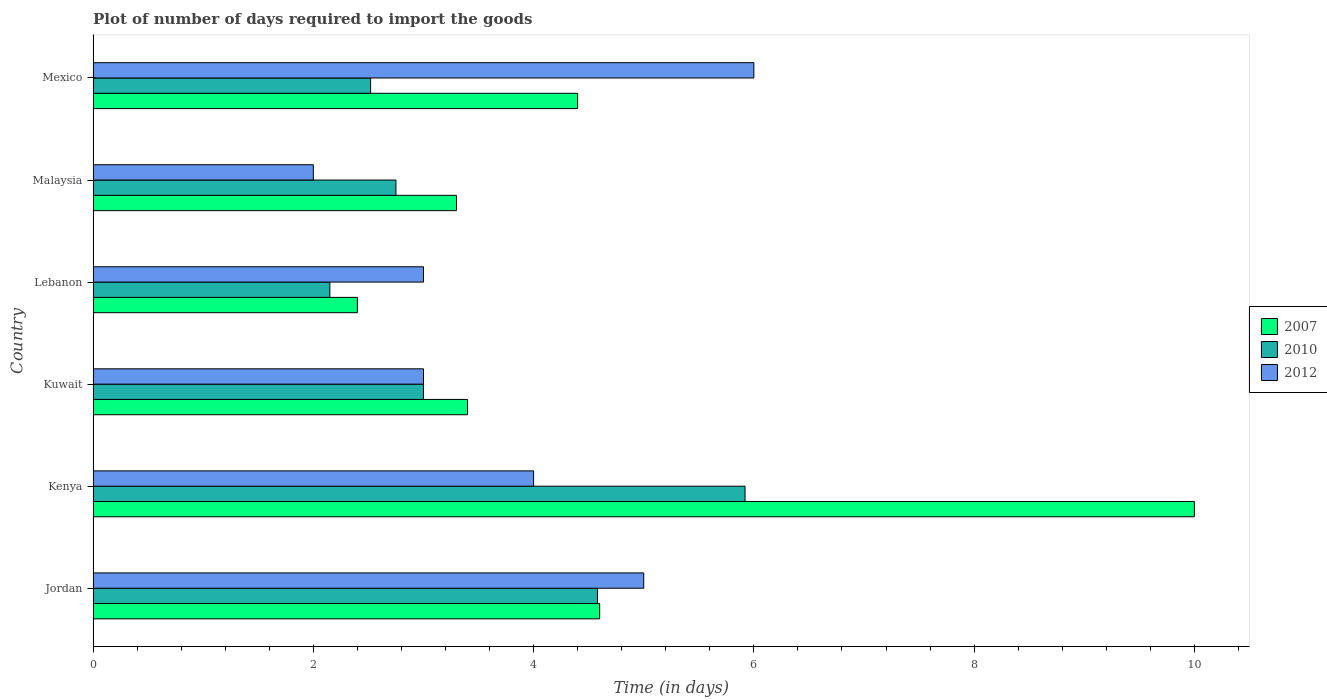How many different coloured bars are there?
Your response must be concise. 3. Are the number of bars per tick equal to the number of legend labels?
Your answer should be compact. Yes. What is the label of the 5th group of bars from the top?
Keep it short and to the point. Kenya. What is the time required to import goods in 2010 in Mexico?
Provide a short and direct response. 2.52. Across all countries, what is the maximum time required to import goods in 2007?
Your response must be concise. 10. Across all countries, what is the minimum time required to import goods in 2010?
Offer a terse response. 2.15. In which country was the time required to import goods in 2007 maximum?
Make the answer very short. Kenya. In which country was the time required to import goods in 2010 minimum?
Keep it short and to the point. Lebanon. What is the total time required to import goods in 2012 in the graph?
Your response must be concise. 23. What is the difference between the time required to import goods in 2007 in Kenya and that in Lebanon?
Give a very brief answer. 7.6. What is the difference between the time required to import goods in 2012 in Jordan and the time required to import goods in 2007 in Mexico?
Provide a short and direct response. 0.6. What is the average time required to import goods in 2007 per country?
Offer a terse response. 4.68. What is the difference between the time required to import goods in 2007 and time required to import goods in 2010 in Lebanon?
Keep it short and to the point. 0.25. In how many countries, is the time required to import goods in 2010 greater than 3.2 days?
Your response must be concise. 2. What is the ratio of the time required to import goods in 2010 in Jordan to that in Kuwait?
Offer a terse response. 1.53. Is the time required to import goods in 2010 in Kenya less than that in Malaysia?
Make the answer very short. No. Is the difference between the time required to import goods in 2007 in Kenya and Lebanon greater than the difference between the time required to import goods in 2010 in Kenya and Lebanon?
Offer a very short reply. Yes. What is the difference between the highest and the second highest time required to import goods in 2012?
Make the answer very short. 1. In how many countries, is the time required to import goods in 2012 greater than the average time required to import goods in 2012 taken over all countries?
Ensure brevity in your answer.  3. Is the sum of the time required to import goods in 2012 in Jordan and Malaysia greater than the maximum time required to import goods in 2010 across all countries?
Keep it short and to the point. Yes. Is it the case that in every country, the sum of the time required to import goods in 2012 and time required to import goods in 2010 is greater than the time required to import goods in 2007?
Your answer should be very brief. No. How many bars are there?
Your response must be concise. 18. Are all the bars in the graph horizontal?
Your response must be concise. Yes. What is the difference between two consecutive major ticks on the X-axis?
Keep it short and to the point. 2. Are the values on the major ticks of X-axis written in scientific E-notation?
Make the answer very short. No. Does the graph contain any zero values?
Provide a succinct answer. No. How many legend labels are there?
Offer a very short reply. 3. What is the title of the graph?
Ensure brevity in your answer.  Plot of number of days required to import the goods. Does "2009" appear as one of the legend labels in the graph?
Provide a succinct answer. No. What is the label or title of the X-axis?
Your answer should be very brief. Time (in days). What is the label or title of the Y-axis?
Give a very brief answer. Country. What is the Time (in days) of 2007 in Jordan?
Offer a terse response. 4.6. What is the Time (in days) in 2010 in Jordan?
Your answer should be very brief. 4.58. What is the Time (in days) in 2007 in Kenya?
Your answer should be very brief. 10. What is the Time (in days) in 2010 in Kenya?
Provide a short and direct response. 5.92. What is the Time (in days) in 2007 in Kuwait?
Offer a very short reply. 3.4. What is the Time (in days) of 2007 in Lebanon?
Your response must be concise. 2.4. What is the Time (in days) in 2010 in Lebanon?
Keep it short and to the point. 2.15. What is the Time (in days) in 2012 in Lebanon?
Offer a terse response. 3. What is the Time (in days) of 2007 in Malaysia?
Your answer should be compact. 3.3. What is the Time (in days) of 2010 in Malaysia?
Provide a succinct answer. 2.75. What is the Time (in days) of 2012 in Malaysia?
Give a very brief answer. 2. What is the Time (in days) in 2007 in Mexico?
Offer a very short reply. 4.4. What is the Time (in days) in 2010 in Mexico?
Keep it short and to the point. 2.52. Across all countries, what is the maximum Time (in days) of 2007?
Your answer should be very brief. 10. Across all countries, what is the maximum Time (in days) in 2010?
Ensure brevity in your answer.  5.92. Across all countries, what is the minimum Time (in days) in 2010?
Keep it short and to the point. 2.15. What is the total Time (in days) of 2007 in the graph?
Make the answer very short. 28.1. What is the total Time (in days) of 2010 in the graph?
Provide a short and direct response. 20.92. What is the total Time (in days) in 2012 in the graph?
Make the answer very short. 23. What is the difference between the Time (in days) in 2010 in Jordan and that in Kenya?
Provide a short and direct response. -1.34. What is the difference between the Time (in days) of 2010 in Jordan and that in Kuwait?
Ensure brevity in your answer.  1.58. What is the difference between the Time (in days) in 2007 in Jordan and that in Lebanon?
Your answer should be very brief. 2.2. What is the difference between the Time (in days) in 2010 in Jordan and that in Lebanon?
Make the answer very short. 2.43. What is the difference between the Time (in days) in 2007 in Jordan and that in Malaysia?
Provide a short and direct response. 1.3. What is the difference between the Time (in days) of 2010 in Jordan and that in Malaysia?
Provide a short and direct response. 1.83. What is the difference between the Time (in days) in 2010 in Jordan and that in Mexico?
Keep it short and to the point. 2.06. What is the difference between the Time (in days) in 2012 in Jordan and that in Mexico?
Give a very brief answer. -1. What is the difference between the Time (in days) in 2007 in Kenya and that in Kuwait?
Give a very brief answer. 6.6. What is the difference between the Time (in days) in 2010 in Kenya and that in Kuwait?
Give a very brief answer. 2.92. What is the difference between the Time (in days) of 2012 in Kenya and that in Kuwait?
Provide a succinct answer. 1. What is the difference between the Time (in days) in 2007 in Kenya and that in Lebanon?
Ensure brevity in your answer.  7.6. What is the difference between the Time (in days) in 2010 in Kenya and that in Lebanon?
Your response must be concise. 3.77. What is the difference between the Time (in days) in 2012 in Kenya and that in Lebanon?
Your response must be concise. 1. What is the difference between the Time (in days) in 2010 in Kenya and that in Malaysia?
Ensure brevity in your answer.  3.17. What is the difference between the Time (in days) in 2012 in Kenya and that in Malaysia?
Give a very brief answer. 2. What is the difference between the Time (in days) in 2007 in Kenya and that in Mexico?
Give a very brief answer. 5.6. What is the difference between the Time (in days) in 2010 in Kenya and that in Mexico?
Provide a short and direct response. 3.4. What is the difference between the Time (in days) of 2012 in Kenya and that in Mexico?
Your answer should be compact. -2. What is the difference between the Time (in days) of 2012 in Kuwait and that in Malaysia?
Ensure brevity in your answer.  1. What is the difference between the Time (in days) of 2010 in Kuwait and that in Mexico?
Keep it short and to the point. 0.48. What is the difference between the Time (in days) of 2012 in Kuwait and that in Mexico?
Keep it short and to the point. -3. What is the difference between the Time (in days) of 2007 in Lebanon and that in Malaysia?
Make the answer very short. -0.9. What is the difference between the Time (in days) in 2012 in Lebanon and that in Malaysia?
Offer a very short reply. 1. What is the difference between the Time (in days) of 2010 in Lebanon and that in Mexico?
Make the answer very short. -0.37. What is the difference between the Time (in days) in 2012 in Lebanon and that in Mexico?
Ensure brevity in your answer.  -3. What is the difference between the Time (in days) in 2010 in Malaysia and that in Mexico?
Ensure brevity in your answer.  0.23. What is the difference between the Time (in days) of 2007 in Jordan and the Time (in days) of 2010 in Kenya?
Your answer should be very brief. -1.32. What is the difference between the Time (in days) of 2010 in Jordan and the Time (in days) of 2012 in Kenya?
Keep it short and to the point. 0.58. What is the difference between the Time (in days) in 2007 in Jordan and the Time (in days) in 2012 in Kuwait?
Your response must be concise. 1.6. What is the difference between the Time (in days) of 2010 in Jordan and the Time (in days) of 2012 in Kuwait?
Your answer should be very brief. 1.58. What is the difference between the Time (in days) of 2007 in Jordan and the Time (in days) of 2010 in Lebanon?
Offer a very short reply. 2.45. What is the difference between the Time (in days) of 2010 in Jordan and the Time (in days) of 2012 in Lebanon?
Make the answer very short. 1.58. What is the difference between the Time (in days) of 2007 in Jordan and the Time (in days) of 2010 in Malaysia?
Provide a succinct answer. 1.85. What is the difference between the Time (in days) of 2010 in Jordan and the Time (in days) of 2012 in Malaysia?
Offer a very short reply. 2.58. What is the difference between the Time (in days) in 2007 in Jordan and the Time (in days) in 2010 in Mexico?
Your answer should be very brief. 2.08. What is the difference between the Time (in days) in 2010 in Jordan and the Time (in days) in 2012 in Mexico?
Keep it short and to the point. -1.42. What is the difference between the Time (in days) in 2007 in Kenya and the Time (in days) in 2012 in Kuwait?
Offer a terse response. 7. What is the difference between the Time (in days) in 2010 in Kenya and the Time (in days) in 2012 in Kuwait?
Your answer should be compact. 2.92. What is the difference between the Time (in days) in 2007 in Kenya and the Time (in days) in 2010 in Lebanon?
Give a very brief answer. 7.85. What is the difference between the Time (in days) of 2010 in Kenya and the Time (in days) of 2012 in Lebanon?
Provide a short and direct response. 2.92. What is the difference between the Time (in days) in 2007 in Kenya and the Time (in days) in 2010 in Malaysia?
Provide a short and direct response. 7.25. What is the difference between the Time (in days) of 2007 in Kenya and the Time (in days) of 2012 in Malaysia?
Offer a terse response. 8. What is the difference between the Time (in days) of 2010 in Kenya and the Time (in days) of 2012 in Malaysia?
Offer a terse response. 3.92. What is the difference between the Time (in days) in 2007 in Kenya and the Time (in days) in 2010 in Mexico?
Ensure brevity in your answer.  7.48. What is the difference between the Time (in days) of 2007 in Kenya and the Time (in days) of 2012 in Mexico?
Provide a short and direct response. 4. What is the difference between the Time (in days) of 2010 in Kenya and the Time (in days) of 2012 in Mexico?
Ensure brevity in your answer.  -0.08. What is the difference between the Time (in days) of 2007 in Kuwait and the Time (in days) of 2010 in Lebanon?
Provide a short and direct response. 1.25. What is the difference between the Time (in days) of 2007 in Kuwait and the Time (in days) of 2010 in Malaysia?
Ensure brevity in your answer.  0.65. What is the difference between the Time (in days) in 2007 in Kuwait and the Time (in days) in 2012 in Malaysia?
Make the answer very short. 1.4. What is the difference between the Time (in days) in 2007 in Lebanon and the Time (in days) in 2010 in Malaysia?
Make the answer very short. -0.35. What is the difference between the Time (in days) of 2007 in Lebanon and the Time (in days) of 2010 in Mexico?
Your answer should be very brief. -0.12. What is the difference between the Time (in days) of 2010 in Lebanon and the Time (in days) of 2012 in Mexico?
Keep it short and to the point. -3.85. What is the difference between the Time (in days) in 2007 in Malaysia and the Time (in days) in 2010 in Mexico?
Provide a short and direct response. 0.78. What is the difference between the Time (in days) of 2007 in Malaysia and the Time (in days) of 2012 in Mexico?
Your answer should be compact. -2.7. What is the difference between the Time (in days) of 2010 in Malaysia and the Time (in days) of 2012 in Mexico?
Keep it short and to the point. -3.25. What is the average Time (in days) of 2007 per country?
Make the answer very short. 4.68. What is the average Time (in days) of 2010 per country?
Your response must be concise. 3.49. What is the average Time (in days) in 2012 per country?
Give a very brief answer. 3.83. What is the difference between the Time (in days) in 2007 and Time (in days) in 2010 in Jordan?
Offer a terse response. 0.02. What is the difference between the Time (in days) of 2010 and Time (in days) of 2012 in Jordan?
Provide a succinct answer. -0.42. What is the difference between the Time (in days) of 2007 and Time (in days) of 2010 in Kenya?
Provide a short and direct response. 4.08. What is the difference between the Time (in days) in 2010 and Time (in days) in 2012 in Kenya?
Provide a short and direct response. 1.92. What is the difference between the Time (in days) in 2007 and Time (in days) in 2012 in Kuwait?
Offer a terse response. 0.4. What is the difference between the Time (in days) in 2007 and Time (in days) in 2010 in Lebanon?
Offer a terse response. 0.25. What is the difference between the Time (in days) in 2007 and Time (in days) in 2012 in Lebanon?
Make the answer very short. -0.6. What is the difference between the Time (in days) of 2010 and Time (in days) of 2012 in Lebanon?
Offer a terse response. -0.85. What is the difference between the Time (in days) in 2007 and Time (in days) in 2010 in Malaysia?
Make the answer very short. 0.55. What is the difference between the Time (in days) in 2007 and Time (in days) in 2012 in Malaysia?
Keep it short and to the point. 1.3. What is the difference between the Time (in days) in 2007 and Time (in days) in 2010 in Mexico?
Your response must be concise. 1.88. What is the difference between the Time (in days) in 2010 and Time (in days) in 2012 in Mexico?
Your answer should be compact. -3.48. What is the ratio of the Time (in days) of 2007 in Jordan to that in Kenya?
Keep it short and to the point. 0.46. What is the ratio of the Time (in days) in 2010 in Jordan to that in Kenya?
Your response must be concise. 0.77. What is the ratio of the Time (in days) of 2007 in Jordan to that in Kuwait?
Offer a terse response. 1.35. What is the ratio of the Time (in days) in 2010 in Jordan to that in Kuwait?
Your answer should be very brief. 1.53. What is the ratio of the Time (in days) of 2007 in Jordan to that in Lebanon?
Your answer should be very brief. 1.92. What is the ratio of the Time (in days) of 2010 in Jordan to that in Lebanon?
Offer a very short reply. 2.13. What is the ratio of the Time (in days) of 2007 in Jordan to that in Malaysia?
Give a very brief answer. 1.39. What is the ratio of the Time (in days) of 2010 in Jordan to that in Malaysia?
Your answer should be very brief. 1.67. What is the ratio of the Time (in days) of 2012 in Jordan to that in Malaysia?
Offer a very short reply. 2.5. What is the ratio of the Time (in days) in 2007 in Jordan to that in Mexico?
Your answer should be compact. 1.05. What is the ratio of the Time (in days) of 2010 in Jordan to that in Mexico?
Provide a short and direct response. 1.82. What is the ratio of the Time (in days) in 2007 in Kenya to that in Kuwait?
Your answer should be compact. 2.94. What is the ratio of the Time (in days) of 2010 in Kenya to that in Kuwait?
Your response must be concise. 1.97. What is the ratio of the Time (in days) in 2012 in Kenya to that in Kuwait?
Give a very brief answer. 1.33. What is the ratio of the Time (in days) of 2007 in Kenya to that in Lebanon?
Ensure brevity in your answer.  4.17. What is the ratio of the Time (in days) in 2010 in Kenya to that in Lebanon?
Provide a short and direct response. 2.75. What is the ratio of the Time (in days) in 2007 in Kenya to that in Malaysia?
Offer a very short reply. 3.03. What is the ratio of the Time (in days) in 2010 in Kenya to that in Malaysia?
Offer a terse response. 2.15. What is the ratio of the Time (in days) in 2007 in Kenya to that in Mexico?
Your answer should be compact. 2.27. What is the ratio of the Time (in days) of 2010 in Kenya to that in Mexico?
Make the answer very short. 2.35. What is the ratio of the Time (in days) in 2012 in Kenya to that in Mexico?
Ensure brevity in your answer.  0.67. What is the ratio of the Time (in days) in 2007 in Kuwait to that in Lebanon?
Your response must be concise. 1.42. What is the ratio of the Time (in days) in 2010 in Kuwait to that in Lebanon?
Provide a short and direct response. 1.4. What is the ratio of the Time (in days) in 2012 in Kuwait to that in Lebanon?
Offer a terse response. 1. What is the ratio of the Time (in days) of 2007 in Kuwait to that in Malaysia?
Make the answer very short. 1.03. What is the ratio of the Time (in days) in 2010 in Kuwait to that in Malaysia?
Offer a very short reply. 1.09. What is the ratio of the Time (in days) of 2007 in Kuwait to that in Mexico?
Provide a succinct answer. 0.77. What is the ratio of the Time (in days) of 2010 in Kuwait to that in Mexico?
Your answer should be compact. 1.19. What is the ratio of the Time (in days) of 2012 in Kuwait to that in Mexico?
Provide a short and direct response. 0.5. What is the ratio of the Time (in days) in 2007 in Lebanon to that in Malaysia?
Your answer should be very brief. 0.73. What is the ratio of the Time (in days) in 2010 in Lebanon to that in Malaysia?
Offer a terse response. 0.78. What is the ratio of the Time (in days) of 2012 in Lebanon to that in Malaysia?
Provide a succinct answer. 1.5. What is the ratio of the Time (in days) of 2007 in Lebanon to that in Mexico?
Offer a very short reply. 0.55. What is the ratio of the Time (in days) of 2010 in Lebanon to that in Mexico?
Your answer should be very brief. 0.85. What is the ratio of the Time (in days) of 2012 in Lebanon to that in Mexico?
Offer a very short reply. 0.5. What is the ratio of the Time (in days) in 2010 in Malaysia to that in Mexico?
Your answer should be very brief. 1.09. What is the ratio of the Time (in days) in 2012 in Malaysia to that in Mexico?
Give a very brief answer. 0.33. What is the difference between the highest and the second highest Time (in days) of 2007?
Your response must be concise. 5.4. What is the difference between the highest and the second highest Time (in days) in 2010?
Your response must be concise. 1.34. What is the difference between the highest and the lowest Time (in days) in 2010?
Keep it short and to the point. 3.77. 